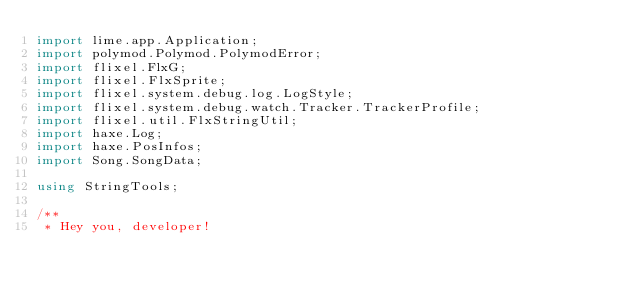Convert code to text. <code><loc_0><loc_0><loc_500><loc_500><_Haxe_>import lime.app.Application;
import polymod.Polymod.PolymodError;
import flixel.FlxG;
import flixel.FlxSprite;
import flixel.system.debug.log.LogStyle;
import flixel.system.debug.watch.Tracker.TrackerProfile;
import flixel.util.FlxStringUtil;
import haxe.Log;
import haxe.PosInfos;
import Song.SongData;

using StringTools;

/**
 * Hey you, developer!</code> 